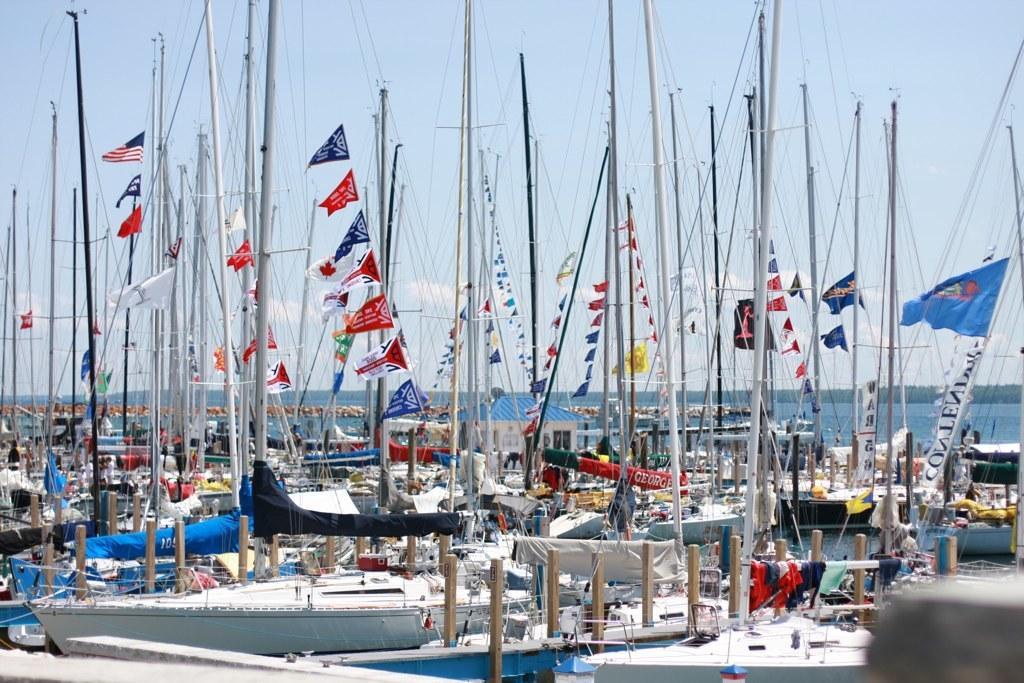Please provide a concise description of this image. In this image we can see ships, flags, poles and other objects. In the background of the image there is water and the sky. 